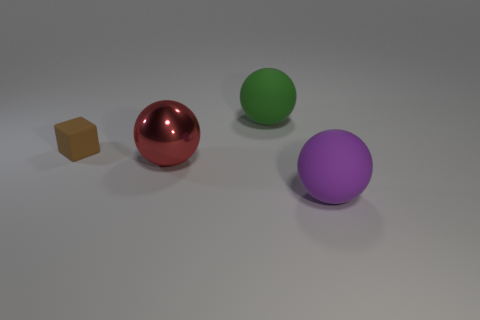Add 4 large red metal spheres. How many objects exist? 8 Subtract all matte spheres. How many spheres are left? 1 Subtract all cubes. How many objects are left? 3 Subtract 1 red spheres. How many objects are left? 3 Subtract all red shiny spheres. Subtract all rubber balls. How many objects are left? 1 Add 1 big red metallic objects. How many big red metallic objects are left? 2 Add 2 large gray rubber spheres. How many large gray rubber spheres exist? 2 